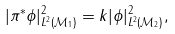<formula> <loc_0><loc_0><loc_500><loc_500>| \pi ^ { * } \phi | ^ { 2 } _ { L ^ { 2 } ( \mathcal { M } _ { 1 } ) } = k | \phi | ^ { 2 } _ { L ^ { 2 } ( \mathcal { M } _ { 2 } ) } ,</formula> 